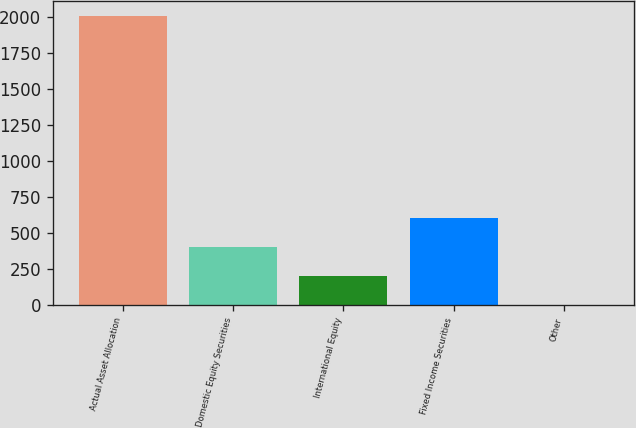Convert chart to OTSL. <chart><loc_0><loc_0><loc_500><loc_500><bar_chart><fcel>Actual Asset Allocation<fcel>Domestic Equity Securities<fcel>International Equity<fcel>Fixed Income Securities<fcel>Other<nl><fcel>2009<fcel>402.6<fcel>201.8<fcel>603.4<fcel>1<nl></chart> 